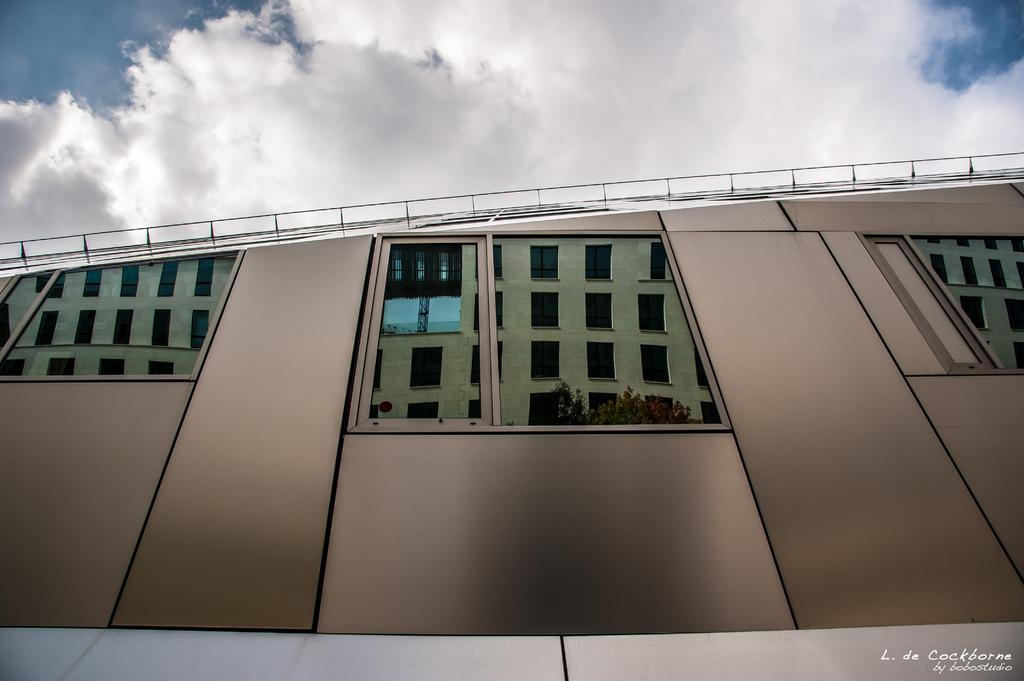What can be seen in the mirror in the image? There is a reflection of buildings with windows in the mirror. What type of vegetation is visible in the image? Trees are visible in the image. What is visible in the background of the image? The sky is visible in the image. What can be observed in the sky? Clouds are present in the sky. What type of hook can be seen hanging from the trees in the image? There is no hook present in the image; it features a reflection of buildings with windows in a mirror, trees, and a sky with clouds. Can you see any bubbles floating in the sky in the image? There are no bubbles present in the image; it features a reflection of buildings with windows in a mirror, trees, and a sky with clouds. 